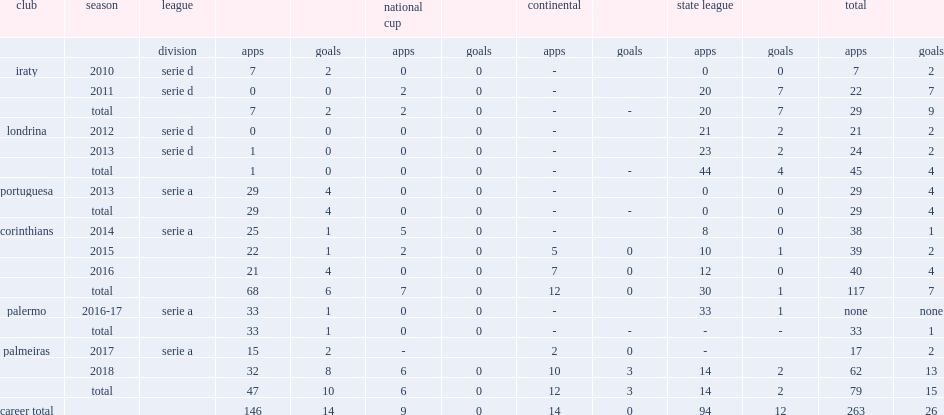Which club did bruno henrique play for in 2012? Londrina. 